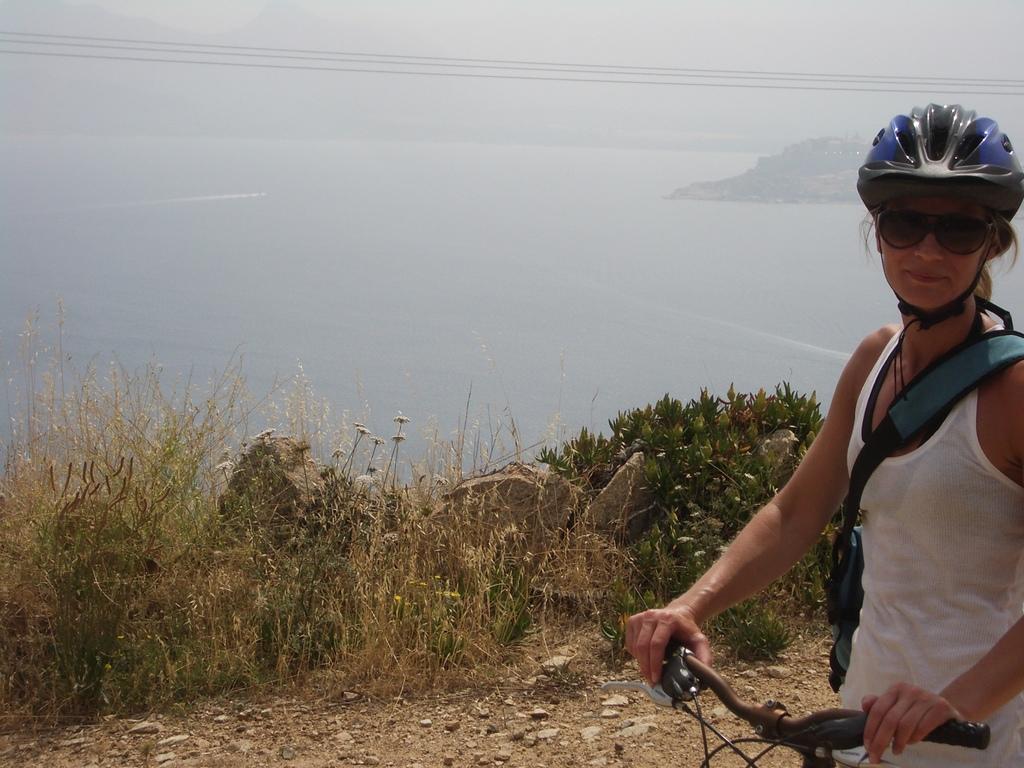Could you give a brief overview of what you see in this image? In this image there is a woman in the center on the right side wearing a blue colour helmet holding a bicycle. In the background there are dry grass and there is water and the sky is cloudy. 